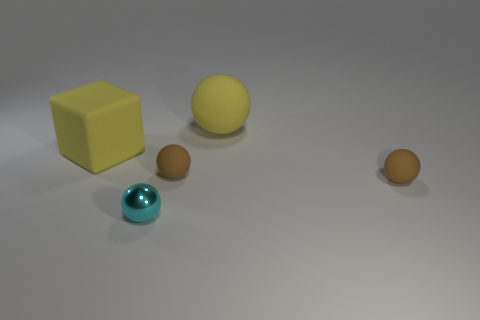Add 1 small brown rubber balls. How many objects exist? 6 Subtract all balls. How many objects are left? 1 Subtract all brown rubber objects. Subtract all big matte cubes. How many objects are left? 2 Add 3 yellow rubber cubes. How many yellow rubber cubes are left? 4 Add 4 red cylinders. How many red cylinders exist? 4 Subtract 0 green cylinders. How many objects are left? 5 